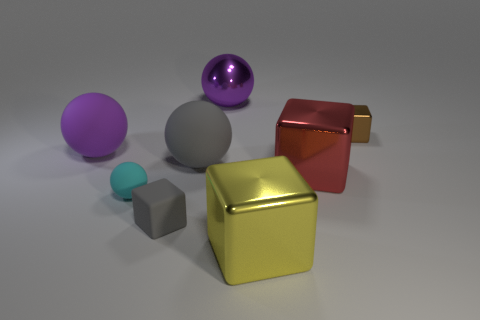Subtract 1 cubes. How many cubes are left? 3 Subtract all brown spheres. Subtract all yellow cubes. How many spheres are left? 4 Add 2 tiny gray rubber objects. How many objects exist? 10 Subtract 0 blue blocks. How many objects are left? 8 Subtract all cyan matte objects. Subtract all large gray objects. How many objects are left? 6 Add 7 large purple matte things. How many large purple matte things are left? 8 Add 3 tiny gray metal balls. How many tiny gray metal balls exist? 3 